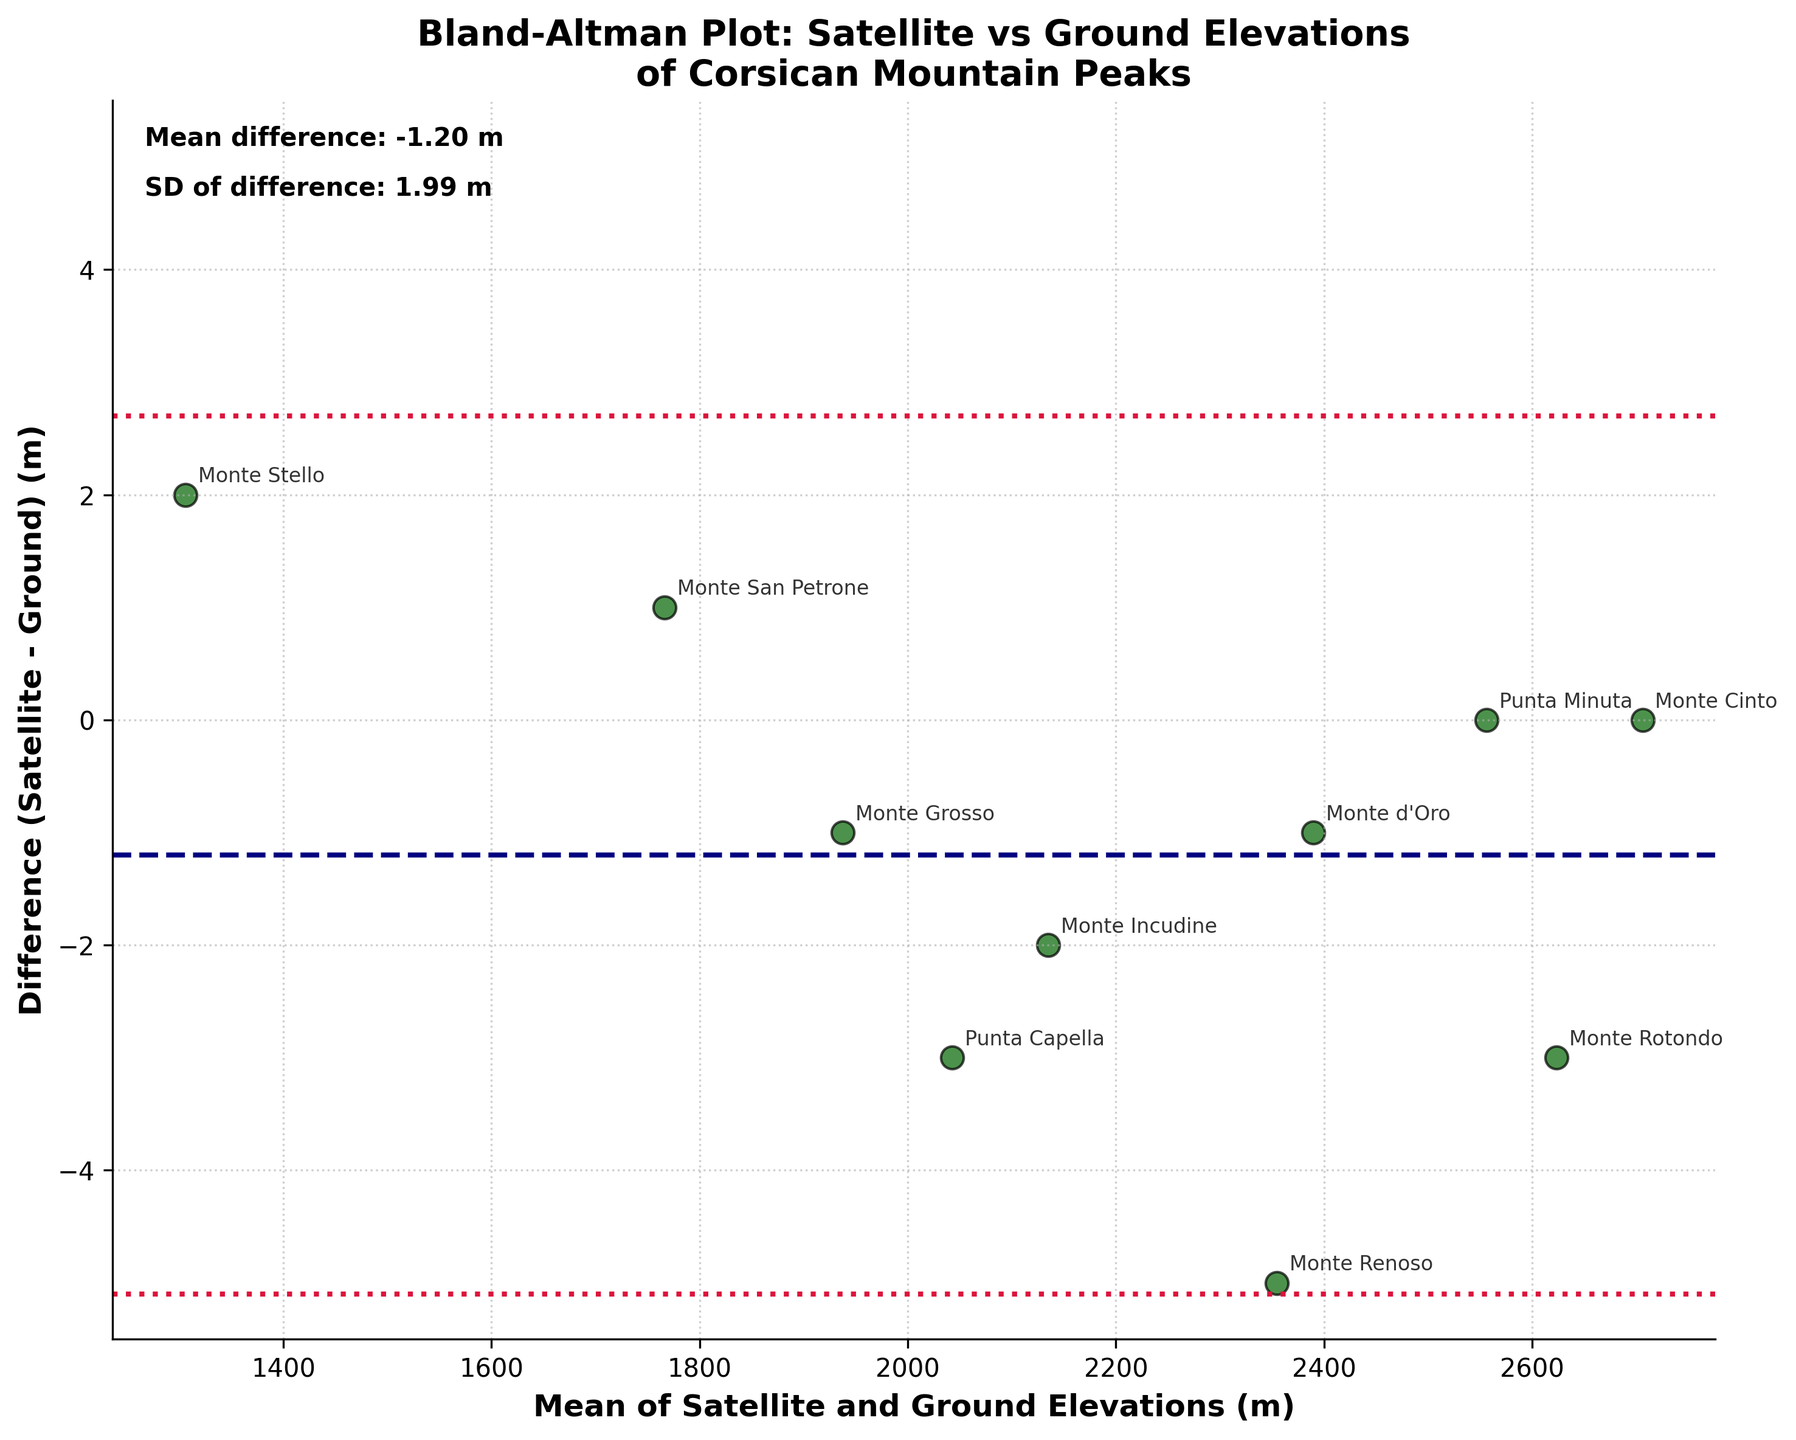what is the main title of the plot? The main title of the plot is the text displayed at the very top, summarizing the entire plot.
Answer: Bland-Altman Plot: Satellite vs Ground Elevations of Corsican Mountain Peaks How many data points are represented in the plot? Count the number of mountain peaks or data points in the scatter plot.
Answer: 10 What does the y-axis represent? The y-axis represents the difference between satellite-derived elevations and ground-measured elevations in meters.
Answer: Difference (Satellite - Ground) (m) What is the color of the mean difference line? The mean difference line is the horizontal line in the plot. Identify its color in the plot.
Answer: Navy Which mountain peak shows the highest positive difference between satellite and ground measurements? Look for the data point with the highest positive value on the y-axis to find which mountain peak it represents.
Answer: Monte Grosso What is the mean difference between satellite-derived and ground-measured elevations? The mean difference is labeled as text on the plot. Read it directly from the plot.
Answer: 0.2 m What are the values of the upper and lower limits of agreement? The upper and lower limits of agreement are usually indicated by dashed lines at ±1.96 standard deviations from the mean difference. The values are shown as text or can be calculated.
Answer: 1.44 m and -1.04 m How does the difference between satellite and ground measurements for Monte Rotondo compare to that for Monte Incudine? Compare the y-values (differences) for Monte Rotondo and Monte Incudine.
Answer: Monte Rotondo has a difference of -3, while Monte Incudine has a difference of -2. So, the difference for Monte Rotondo is larger in magnitude What is the range of the y-axis on the plot? The y-range extends from the minimum to the maximum value of the differences. These limits are marked on the y-axis.
Answer: Between -2 and 2 Which data point falls exactly on the mean difference line? Find the data point whose difference equals the mean difference.
Answer: Monte Incudine 